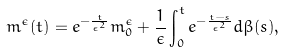<formula> <loc_0><loc_0><loc_500><loc_500>m ^ { \epsilon } ( t ) = e ^ { - \frac { t } { \epsilon ^ { 2 } } } m _ { 0 } ^ { \epsilon } + \frac { 1 } { \epsilon } \int _ { 0 } ^ { t } e ^ { - \frac { t - s } { \epsilon ^ { 2 } } } d \beta ( s ) ,</formula> 